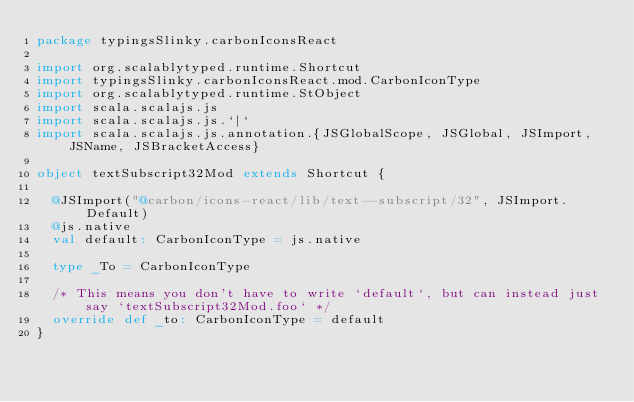<code> <loc_0><loc_0><loc_500><loc_500><_Scala_>package typingsSlinky.carbonIconsReact

import org.scalablytyped.runtime.Shortcut
import typingsSlinky.carbonIconsReact.mod.CarbonIconType
import org.scalablytyped.runtime.StObject
import scala.scalajs.js
import scala.scalajs.js.`|`
import scala.scalajs.js.annotation.{JSGlobalScope, JSGlobal, JSImport, JSName, JSBracketAccess}

object textSubscript32Mod extends Shortcut {
  
  @JSImport("@carbon/icons-react/lib/text--subscript/32", JSImport.Default)
  @js.native
  val default: CarbonIconType = js.native
  
  type _To = CarbonIconType
  
  /* This means you don't have to write `default`, but can instead just say `textSubscript32Mod.foo` */
  override def _to: CarbonIconType = default
}
</code> 